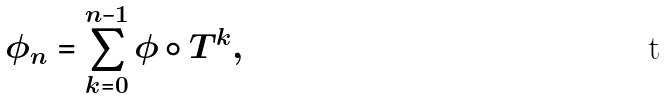Convert formula to latex. <formula><loc_0><loc_0><loc_500><loc_500>\phi _ { n } = \sum _ { k = 0 } ^ { n - 1 } \phi \circ T ^ { k } ,</formula> 